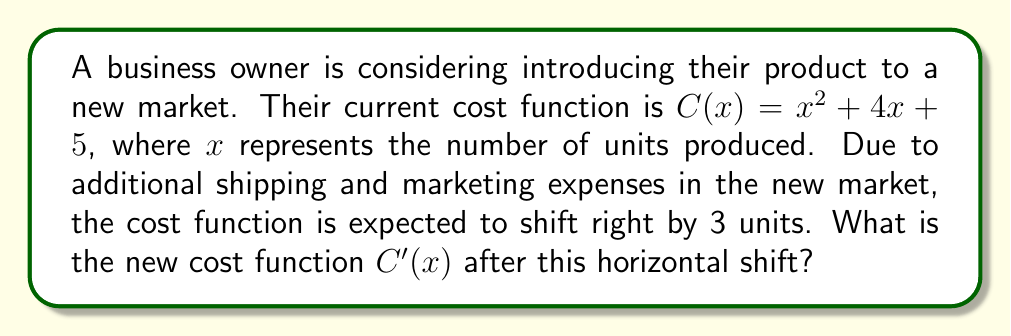Give your solution to this math problem. To determine the new cost function after a horizontal shift, we follow these steps:

1. Recall that a horizontal shift of $h$ units to the right is represented by replacing $x$ with $(x - h)$ in the original function.

2. In this case, the shift is 3 units to the right, so $h = 3$.

3. We start with the original cost function:
   $C(x) = x^2 + 4x + 5$

4. Replace every $x$ in the original function with $(x - 3)$:
   $C'(x) = (x - 3)^2 + 4(x - 3) + 5$

5. Expand the squared term:
   $C'(x) = (x^2 - 6x + 9) + 4(x - 3) + 5$

6. Distribute the 4:
   $C'(x) = (x^2 - 6x + 9) + (4x - 12) + 5$

7. Combine like terms:
   $C'(x) = x^2 - 6x + 9 + 4x - 12 + 5$
   $C'(x) = x^2 - 2x + 2$

Therefore, the new cost function after the horizontal shift is $C'(x) = x^2 - 2x + 2$.
Answer: $C'(x) = x^2 - 2x + 2$ 